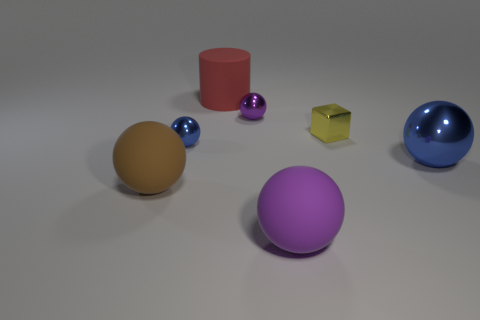Subtract all blocks. How many objects are left? 6 Subtract 1 blocks. How many blocks are left? 0 Subtract all gray cubes. Subtract all blue cylinders. How many cubes are left? 1 Subtract all brown cubes. How many red spheres are left? 0 Subtract all cyan metallic objects. Subtract all purple rubber spheres. How many objects are left? 6 Add 7 rubber spheres. How many rubber spheres are left? 9 Add 4 cyan rubber spheres. How many cyan rubber spheres exist? 4 Add 1 large blocks. How many objects exist? 8 Subtract all purple spheres. How many spheres are left? 3 Subtract all brown matte balls. How many balls are left? 4 